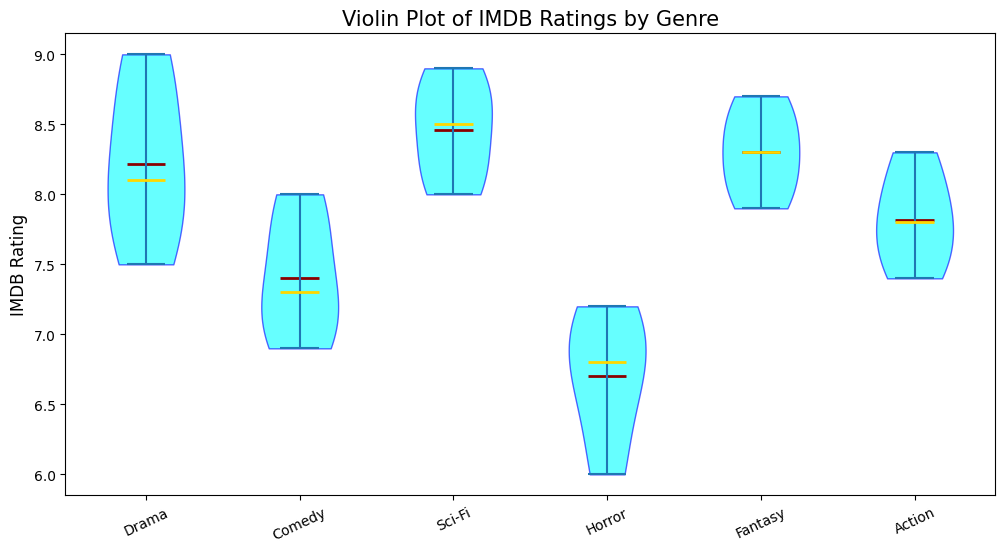What is the median IMDB rating for the Drama genre? Drama's violin plot includes a line indicating the median, which appears as the central tendency. The median is the middle value among the sorted IMDB ratings of the Drama genre.
Answer: 8.1 Which genre has the highest median IMDB rating? By examining the median lines across all genres in the plot, the one with the highest position indicates the highest median.
Answer: Sci-Fi Compare the range of IMDB ratings between Comedy and Horror genres. Which one is broader? The range of the IMDB ratings for each genre can be determined by the width of the respective violin plot. The Comedy genre's range spans from about 6.9 to 8.0, while the Horror genre spans from about 6.0 to 7.2.
Answer: Comedy Which genre has the lowest mean IMDB rating, and what could indicate this visually? The line indicating the mean is typically at the center of the density in the violin plot. Comparing these lines, the genre with the lowest mean can be identified.
Answer: Horror For the Action genre, compare the heights of the lower and upper halves of the violin plot without considering the median. Which half is taller? The height of the violin plot above and below the median divides the dataset into two halves. Observing the vertical spread of the plot indicates that the upper half, representing higher IMDB ratings, is taller.
Answer: Upper half Determine the genre with the most skewed distribution of IMDB ratings. How is this visible? Skewness can be identified by the asymmetry in the violin plot. The plot’s longer tail in one direction signifies the skew.
Answer: Horror Compare the extreme IMDB ratings for Fantasy and Action genres. Which one extends higher? By looking at the top of the violin plots for each genre, the uppermost point represents the extreme/highest IMDB rating.
Answer: Fantasy Evaluate the consistency of IMDB ratings within the Sci-Fi genre. Is it more consistent than Drama? Consistency is demonstrated by the density and spread of the violin plot. Sci-Fi’s plot is narrower with a concentrated density, indicating higher consistency while Drama’s plot is more spread out.
Answer: Yes Identify the genre with the largest interquartile range (IQR) of IMDB ratings. How is this determined? The IQR can be inferred by the height difference between the first and third quartiles. The genre with the widest gap in the middle 50% of the distribution has the largest IQR.
Answer: Action If you were to choose a genre based on the reliability of high ratings (less variation), which one would you pick based on the plot? The genre with the least variation can be identified by the narrowness and density of the central part of the violin plot.
Answer: Sci-Fi 